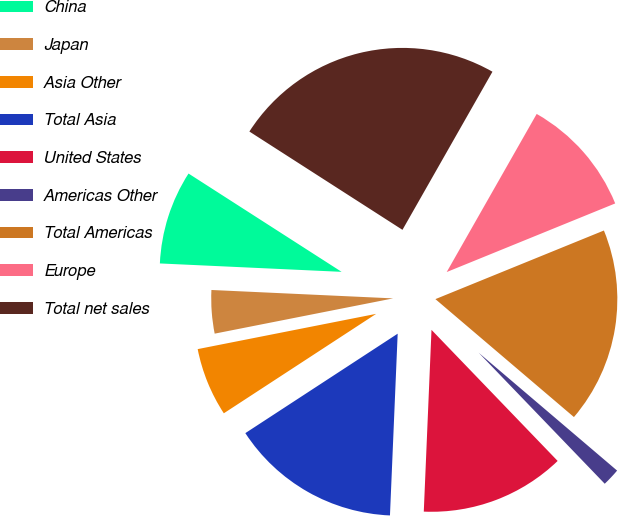Convert chart. <chart><loc_0><loc_0><loc_500><loc_500><pie_chart><fcel>China<fcel>Japan<fcel>Asia Other<fcel>Total Asia<fcel>United States<fcel>Americas Other<fcel>Total Americas<fcel>Europe<fcel>Total net sales<nl><fcel>8.35%<fcel>3.84%<fcel>6.1%<fcel>15.12%<fcel>12.87%<fcel>1.58%<fcel>17.38%<fcel>10.61%<fcel>24.15%<nl></chart> 